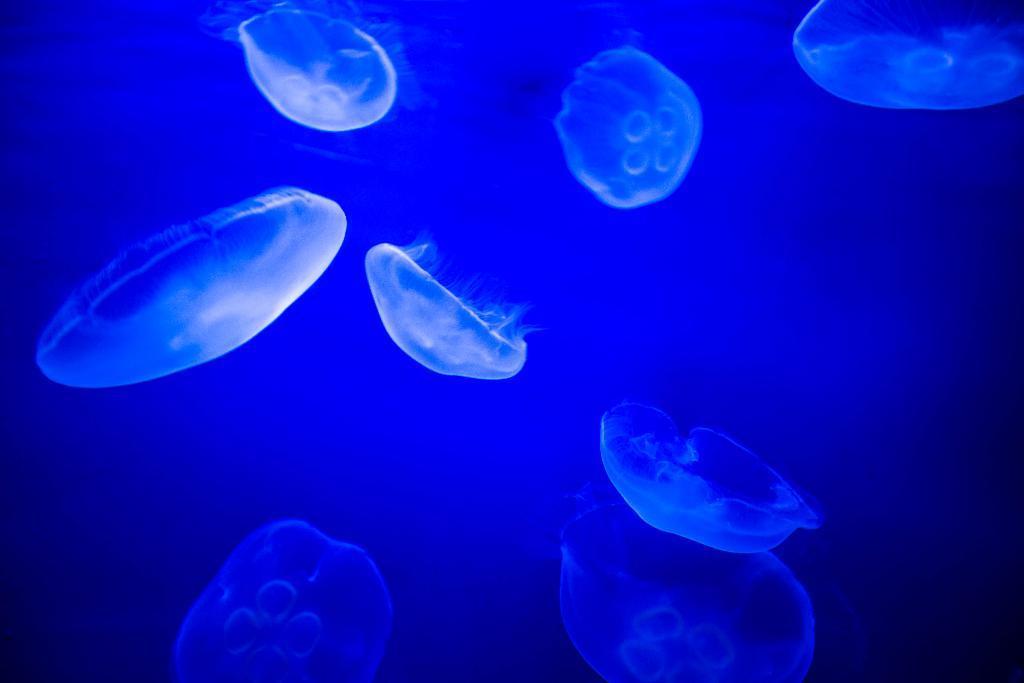In one or two sentences, can you explain what this image depicts? In this image, we can see some undefined object in the background we can see the blue. 